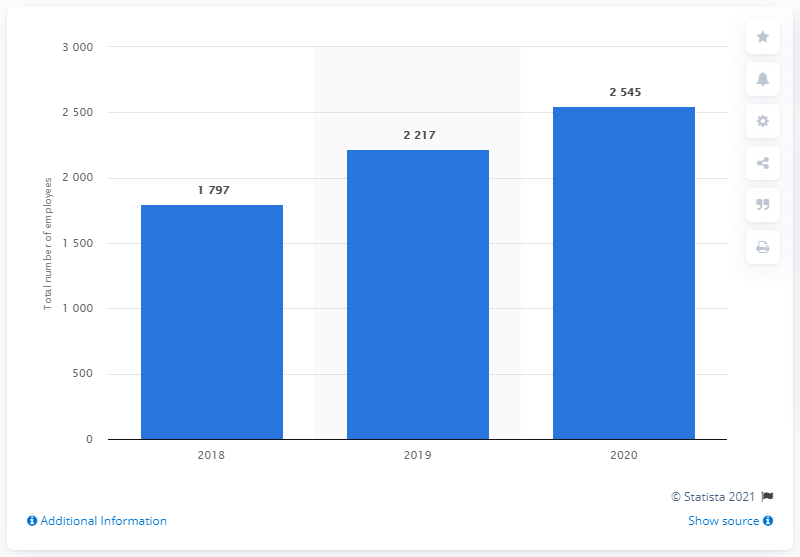Outline some significant characteristics in this image. At the end of fiscal year 2020, Pinterest had a total of 2,545 full-time employees. 